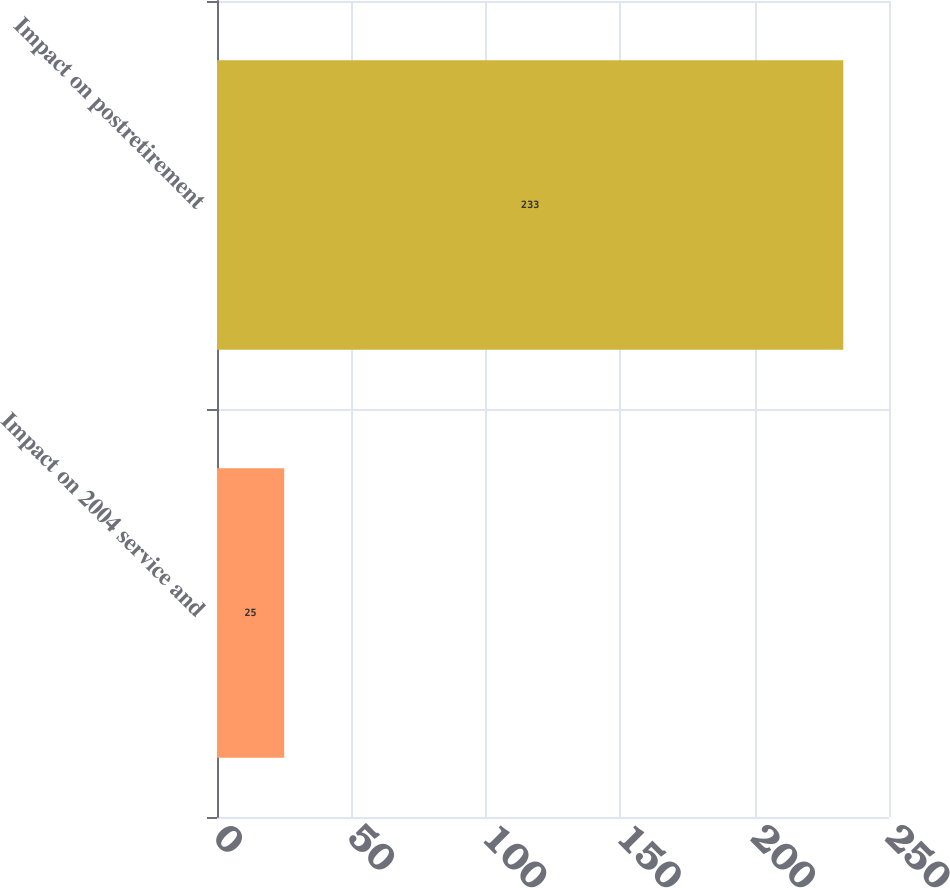Convert chart. <chart><loc_0><loc_0><loc_500><loc_500><bar_chart><fcel>Impact on 2004 service and<fcel>Impact on postretirement<nl><fcel>25<fcel>233<nl></chart> 